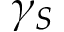<formula> <loc_0><loc_0><loc_500><loc_500>\gamma _ { S }</formula> 